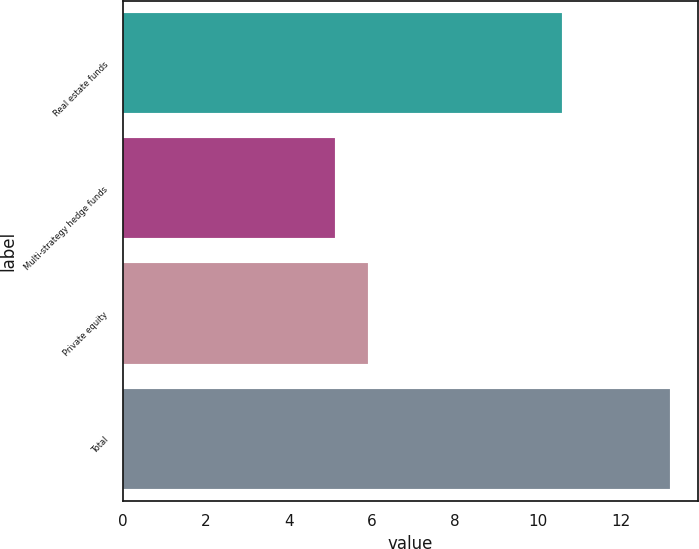<chart> <loc_0><loc_0><loc_500><loc_500><bar_chart><fcel>Real estate funds<fcel>Multi-strategy hedge funds<fcel>Private equity<fcel>Total<nl><fcel>10.6<fcel>5.1<fcel>5.91<fcel>13.2<nl></chart> 